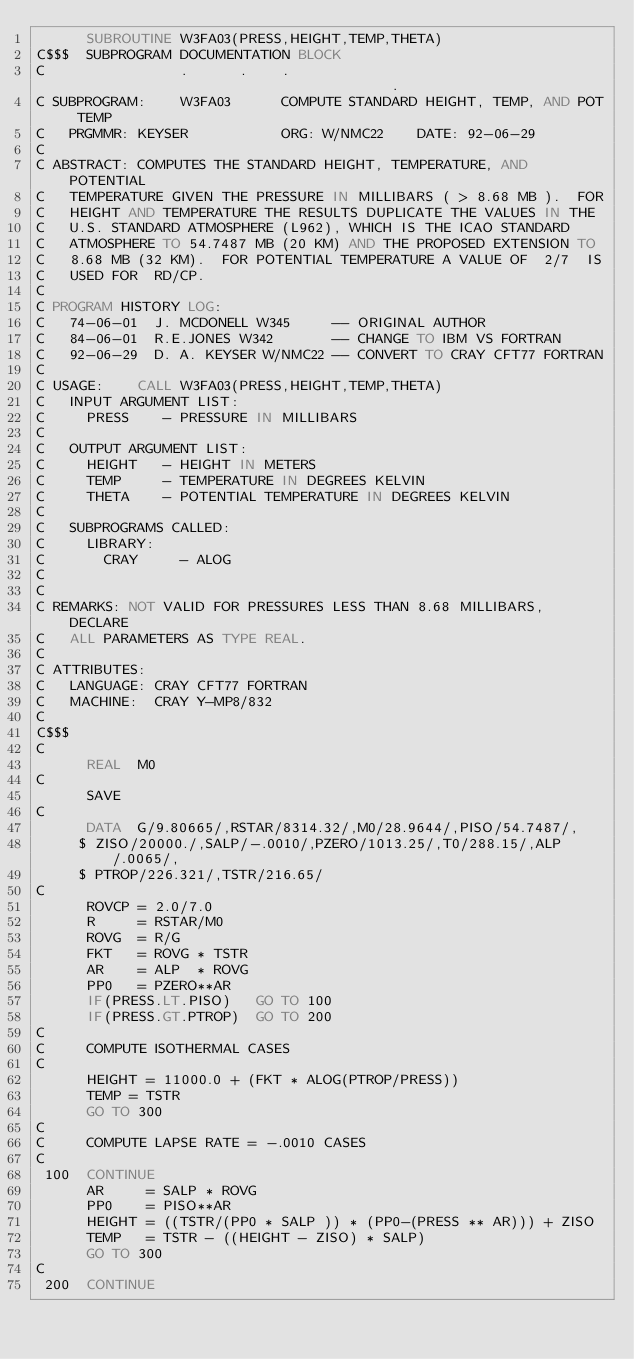Convert code to text. <code><loc_0><loc_0><loc_500><loc_500><_FORTRAN_>      SUBROUTINE W3FA03(PRESS,HEIGHT,TEMP,THETA)
C$$$  SUBPROGRAM DOCUMENTATION BLOCK
C                .      .    .                                       .
C SUBPROGRAM:    W3FA03      COMPUTE STANDARD HEIGHT, TEMP, AND POT TEMP
C   PRGMMR: KEYSER           ORG: W/NMC22    DATE: 92-06-29
C
C ABSTRACT: COMPUTES THE STANDARD HEIGHT, TEMPERATURE, AND POTENTIAL
C   TEMPERATURE GIVEN THE PRESSURE IN MILLIBARS ( > 8.68 MB ).  FOR
C   HEIGHT AND TEMPERATURE THE RESULTS DUPLICATE THE VALUES IN THE
C   U.S. STANDARD ATMOSPHERE (L962), WHICH IS THE ICAO STANDARD
C   ATMOSPHERE TO 54.7487 MB (20 KM) AND THE PROPOSED EXTENSION TO
C   8.68 MB (32 KM).  FOR POTENTIAL TEMPERATURE A VALUE OF  2/7  IS
C   USED FOR  RD/CP.
C
C PROGRAM HISTORY LOG:
C   74-06-01  J. MCDONELL W345     -- ORIGINAL AUTHOR
C   84-06-01  R.E.JONES W342       -- CHANGE TO IBM VS FORTRAN
C   92-06-29  D. A. KEYSER W/NMC22 -- CONVERT TO CRAY CFT77 FORTRAN
C
C USAGE:    CALL W3FA03(PRESS,HEIGHT,TEMP,THETA)
C   INPUT ARGUMENT LIST:
C     PRESS    - PRESSURE IN MILLIBARS
C
C   OUTPUT ARGUMENT LIST:
C     HEIGHT   - HEIGHT IN METERS
C     TEMP     - TEMPERATURE IN DEGREES KELVIN
C     THETA    - POTENTIAL TEMPERATURE IN DEGREES KELVIN
C
C   SUBPROGRAMS CALLED:
C     LIBRARY:
C       CRAY     - ALOG
C
C
C REMARKS: NOT VALID FOR PRESSURES LESS THAN 8.68 MILLIBARS, DECLARE
C   ALL PARAMETERS AS TYPE REAL.
C
C ATTRIBUTES:
C   LANGUAGE: CRAY CFT77 FORTRAN
C   MACHINE:  CRAY Y-MP8/832
C
C$$$
C
      REAL  M0
C
      SAVE
C
      DATA  G/9.80665/,RSTAR/8314.32/,M0/28.9644/,PISO/54.7487/,
     $ ZISO/20000./,SALP/-.0010/,PZERO/1013.25/,T0/288.15/,ALP/.0065/,
     $ PTROP/226.321/,TSTR/216.65/
C
      ROVCP = 2.0/7.0
      R     = RSTAR/M0
      ROVG  = R/G
      FKT   = ROVG * TSTR
      AR    = ALP  * ROVG
      PP0   = PZERO**AR
      IF(PRESS.LT.PISO)   GO TO 100
      IF(PRESS.GT.PTROP)  GO TO 200
C
C     COMPUTE ISOTHERMAL CASES
C
      HEIGHT = 11000.0 + (FKT * ALOG(PTROP/PRESS))
      TEMP = TSTR
      GO TO 300
C
C     COMPUTE LAPSE RATE = -.0010 CASES
C
 100  CONTINUE
      AR     = SALP * ROVG
      PP0    = PISO**AR
      HEIGHT = ((TSTR/(PP0 * SALP )) * (PP0-(PRESS ** AR))) + ZISO
      TEMP   = TSTR - ((HEIGHT - ZISO) * SALP)
      GO TO 300
C
 200  CONTINUE</code> 